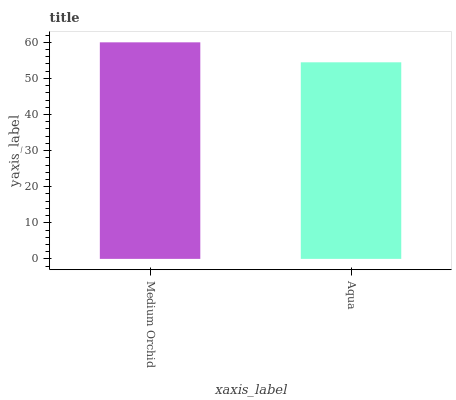Is Aqua the minimum?
Answer yes or no. Yes. Is Medium Orchid the maximum?
Answer yes or no. Yes. Is Aqua the maximum?
Answer yes or no. No. Is Medium Orchid greater than Aqua?
Answer yes or no. Yes. Is Aqua less than Medium Orchid?
Answer yes or no. Yes. Is Aqua greater than Medium Orchid?
Answer yes or no. No. Is Medium Orchid less than Aqua?
Answer yes or no. No. Is Medium Orchid the high median?
Answer yes or no. Yes. Is Aqua the low median?
Answer yes or no. Yes. Is Aqua the high median?
Answer yes or no. No. Is Medium Orchid the low median?
Answer yes or no. No. 